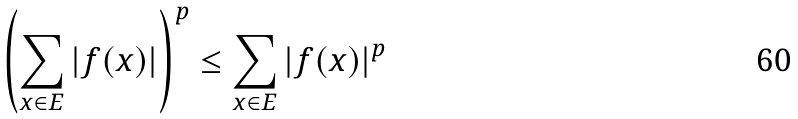Convert formula to latex. <formula><loc_0><loc_0><loc_500><loc_500>\left ( \sum _ { x \in E } | f ( x ) | \right ) ^ { p } \leq \sum _ { x \in E } | f ( x ) | ^ { p }</formula> 